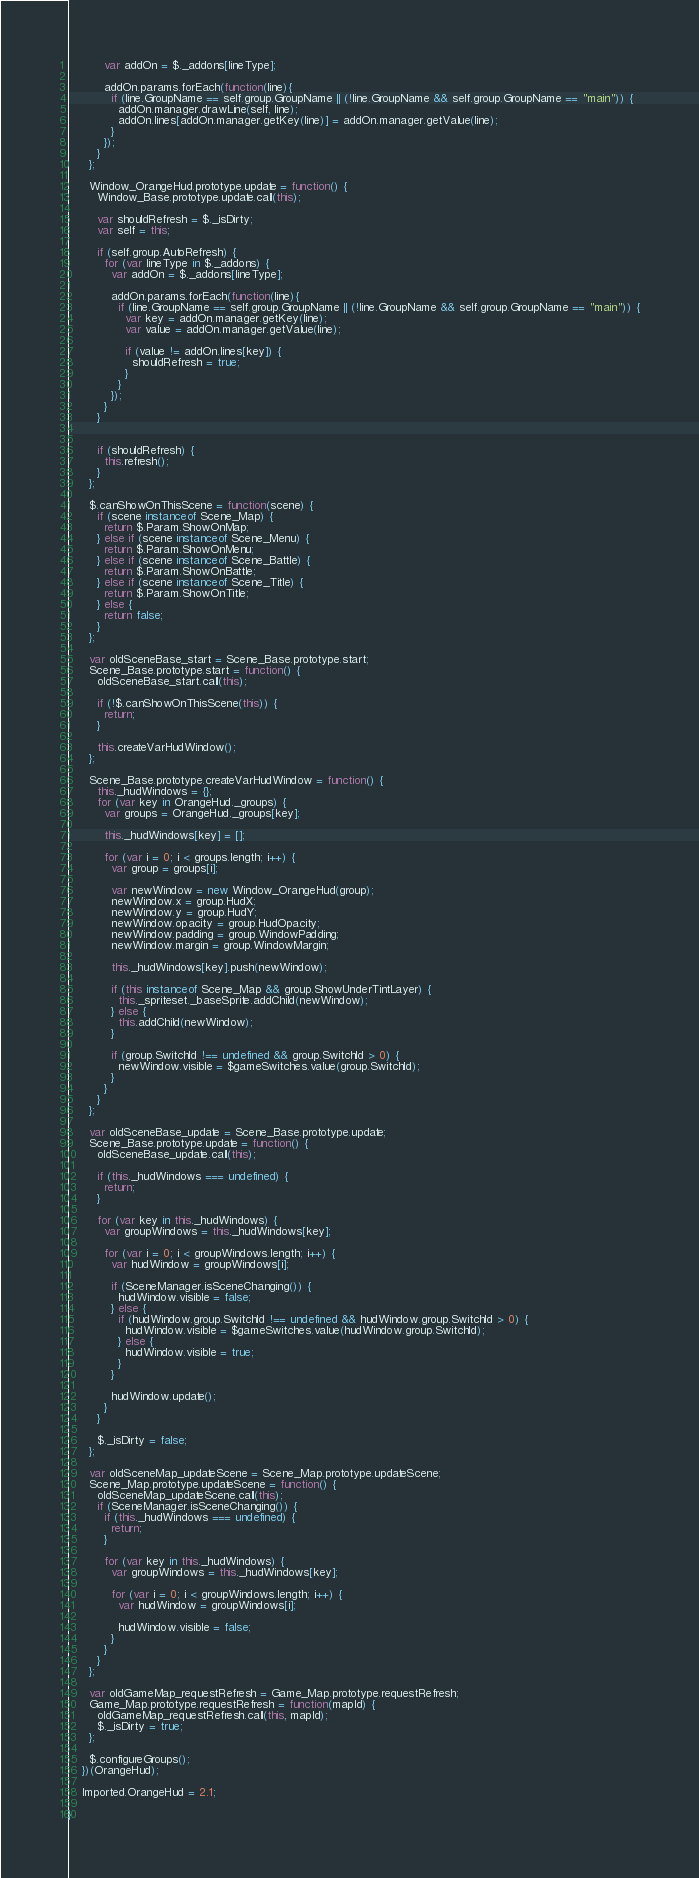<code> <loc_0><loc_0><loc_500><loc_500><_JavaScript_>          var addOn = $._addons[lineType];

          addOn.params.forEach(function(line){
            if (line.GroupName == self.group.GroupName || (!line.GroupName && self.group.GroupName == "main")) {
              addOn.manager.drawLine(self, line);
              addOn.lines[addOn.manager.getKey(line)] = addOn.manager.getValue(line);
            }
          });
        }
      };

      Window_OrangeHud.prototype.update = function() {
        Window_Base.prototype.update.call(this);

        var shouldRefresh = $._isDirty;
        var self = this;

        if (self.group.AutoRefresh) {
          for (var lineType in $._addons) {
            var addOn = $._addons[lineType];

            addOn.params.forEach(function(line){
              if (line.GroupName == self.group.GroupName || (!line.GroupName && self.group.GroupName == "main")) {
                var key = addOn.manager.getKey(line);
                var value = addOn.manager.getValue(line);

                if (value != addOn.lines[key]) {
                  shouldRefresh = true;
                }
              }
            });
          }
        }


        if (shouldRefresh) {
          this.refresh();
        }
      };

      $.canShowOnThisScene = function(scene) {
        if (scene instanceof Scene_Map) {
          return $.Param.ShowOnMap;
        } else if (scene instanceof Scene_Menu) {
          return $.Param.ShowOnMenu;
        } else if (scene instanceof Scene_Battle) {
          return $.Param.ShowOnBattle;
        } else if (scene instanceof Scene_Title) {
          return $.Param.ShowOnTitle;
        } else {
          return false;
        }
      };

      var oldSceneBase_start = Scene_Base.prototype.start;
      Scene_Base.prototype.start = function() {
        oldSceneBase_start.call(this);

        if (!$.canShowOnThisScene(this)) {
          return;
        }

        this.createVarHudWindow();
      };

      Scene_Base.prototype.createVarHudWindow = function() {
        this._hudWindows = {};
        for (var key in OrangeHud._groups) {
          var groups = OrangeHud._groups[key];

          this._hudWindows[key] = [];

          for (var i = 0; i < groups.length; i++) {
            var group = groups[i];

            var newWindow = new Window_OrangeHud(group);
            newWindow.x = group.HudX;
            newWindow.y = group.HudY;
            newWindow.opacity = group.HudOpacity;
            newWindow.padding = group.WindowPadding;
            newWindow.margin = group.WindowMargin;

            this._hudWindows[key].push(newWindow);

            if (this instanceof Scene_Map && group.ShowUnderTintLayer) {
              this._spriteset._baseSprite.addChild(newWindow);
            } else {
              this.addChild(newWindow);
            }

            if (group.SwitchId !== undefined && group.SwitchId > 0) {
              newWindow.visible = $gameSwitches.value(group.SwitchId);
            }
          }
        }
      };

      var oldSceneBase_update = Scene_Base.prototype.update;
      Scene_Base.prototype.update = function() {
        oldSceneBase_update.call(this);

        if (this._hudWindows === undefined) {
          return;
        }

        for (var key in this._hudWindows) {
          var groupWindows = this._hudWindows[key];

          for (var i = 0; i < groupWindows.length; i++) {
            var hudWindow = groupWindows[i];

            if (SceneManager.isSceneChanging()) {
              hudWindow.visible = false;
            } else {
              if (hudWindow.group.SwitchId !== undefined && hudWindow.group.SwitchId > 0) {
                hudWindow.visible = $gameSwitches.value(hudWindow.group.SwitchId);
              } else {
                hudWindow.visible = true;
              }
            }

            hudWindow.update();
          }
        }

        $._isDirty = false;
      };

      var oldSceneMap_updateScene = Scene_Map.prototype.updateScene;
      Scene_Map.prototype.updateScene = function() {
        oldSceneMap_updateScene.call(this);
        if (SceneManager.isSceneChanging()) {
          if (this._hudWindows === undefined) {
            return;
          }

          for (var key in this._hudWindows) {
            var groupWindows = this._hudWindows[key];

            for (var i = 0; i < groupWindows.length; i++) {
              var hudWindow = groupWindows[i];

              hudWindow.visible = false;
            }
          }
        }
      };

      var oldGameMap_requestRefresh = Game_Map.prototype.requestRefresh;
      Game_Map.prototype.requestRefresh = function(mapId) {
        oldGameMap_requestRefresh.call(this, mapId);
        $._isDirty = true;
      };

      $.configureGroups();
    })(OrangeHud);

    Imported.OrangeHud = 2.1;

}
</code> 